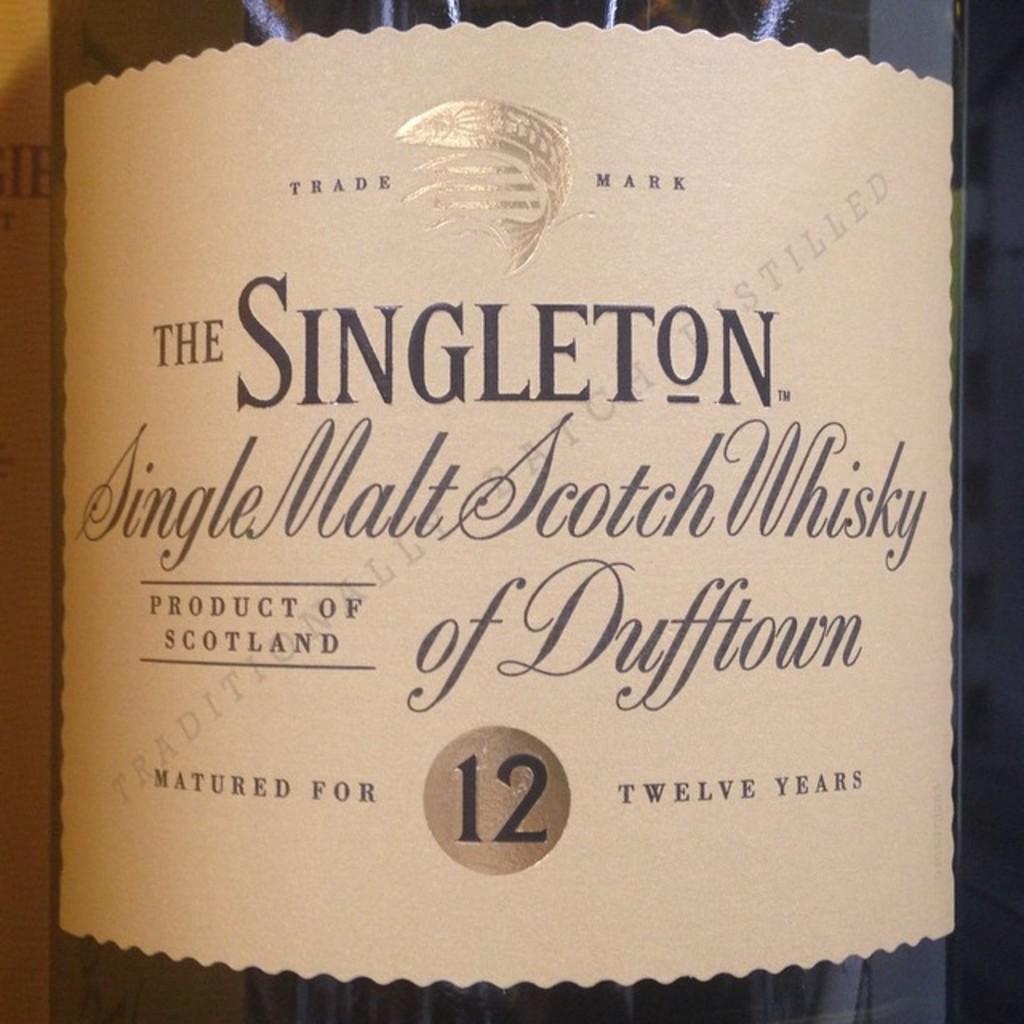Can you describe this image briefly? In the foreground of this image, there is a bottle and a paper wrapped to the bottle and also we can see text on it. 